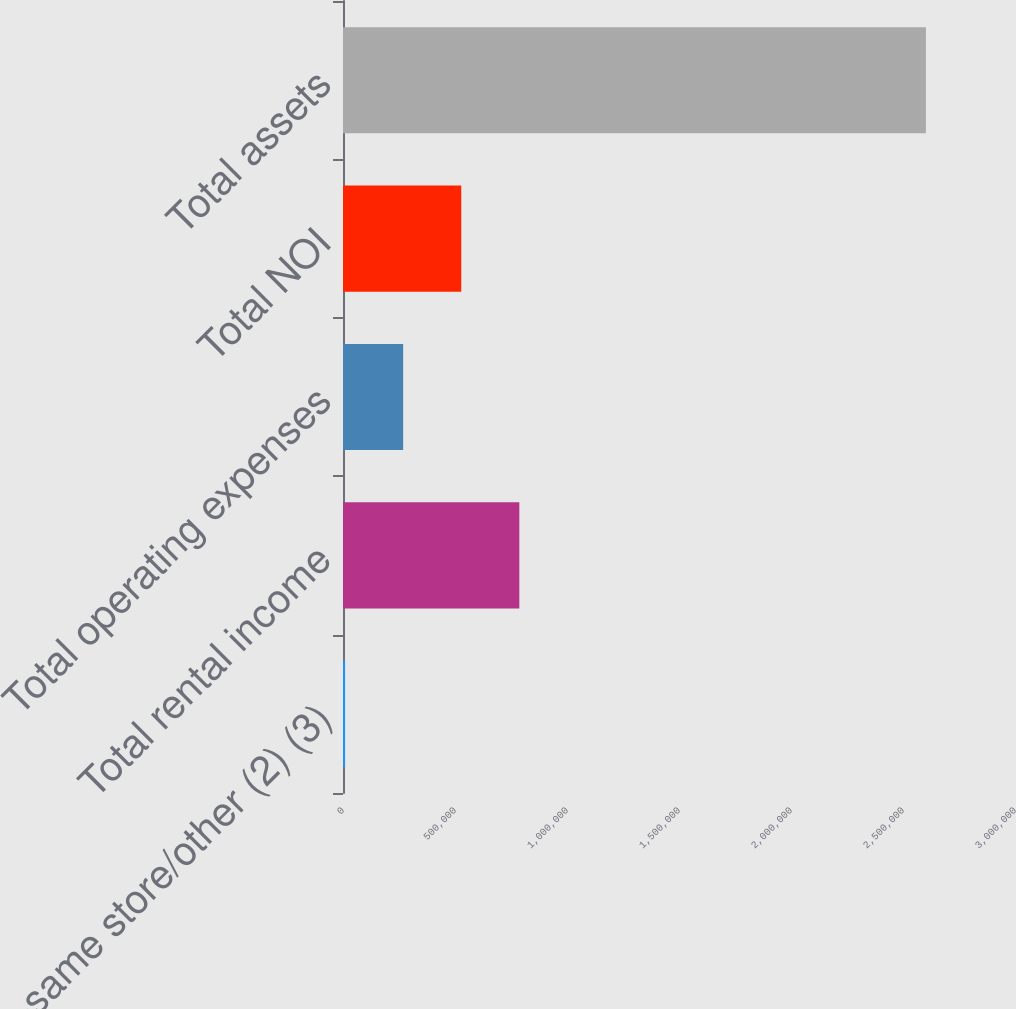<chart> <loc_0><loc_0><loc_500><loc_500><bar_chart><fcel>Non-same store/other (2) (3)<fcel>Total rental income<fcel>Total operating expenses<fcel>Total NOI<fcel>Total assets<nl><fcel>9271<fcel>787185<fcel>268576<fcel>527880<fcel>2.60232e+06<nl></chart> 